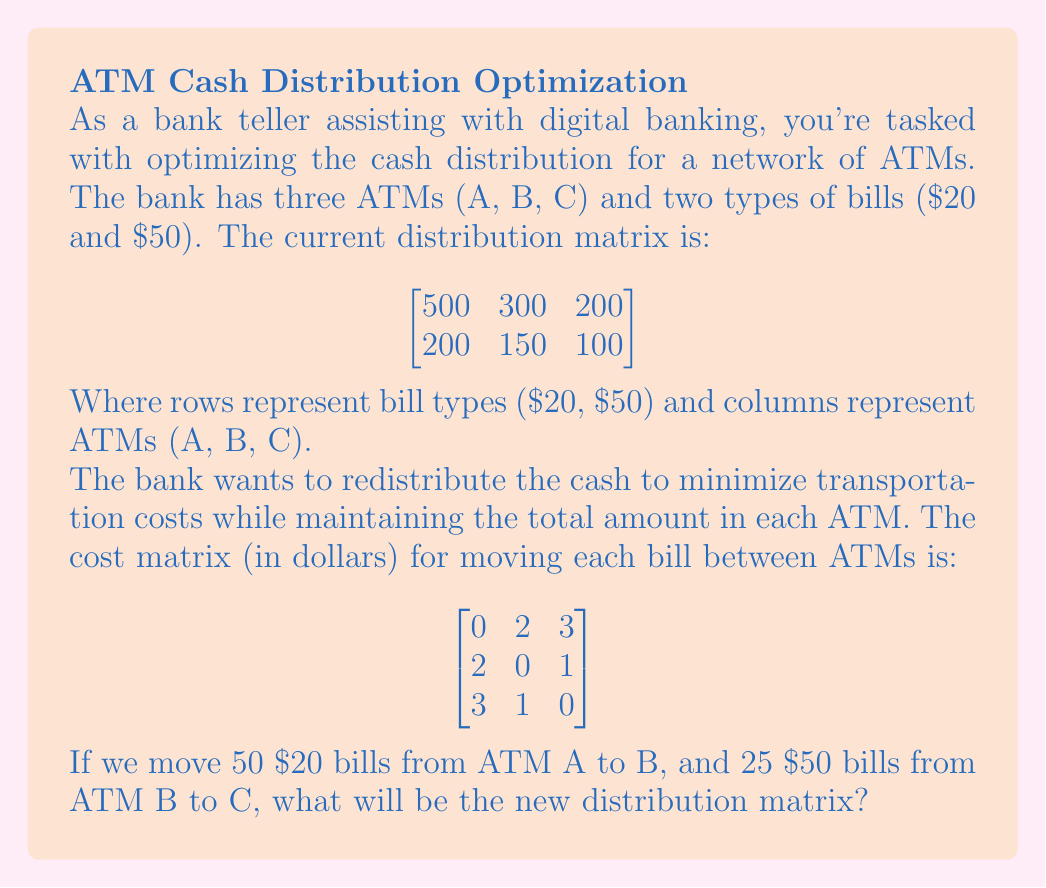Show me your answer to this math problem. Let's approach this step-by-step:

1) First, let's identify the changes:
   - 50 $20 bills move from A to B
   - 25 $50 bills move from B to C

2) For the $20 bills (first row of the matrix):
   - ATM A loses 50: $500 - 50 = 450$
   - ATM B gains 50: $300 + 50 = 350$
   - ATM C remains unchanged: $200$

3) For the $50 bills (second row of the matrix):
   - ATM A remains unchanged: $200$
   - ATM B loses 25: $150 - 25 = 125$
   - ATM C gains 25: $100 + 25 = 125$

4) Now we can construct the new distribution matrix:

$$
\begin{bmatrix}
450 & 350 & 200 \\
200 & 125 & 125
\end{bmatrix}
$$

This new matrix represents the optimized cash distribution after the specified movements.
Answer: $$
\begin{bmatrix}
450 & 350 & 200 \\
200 & 125 & 125
\end{bmatrix}
$$ 